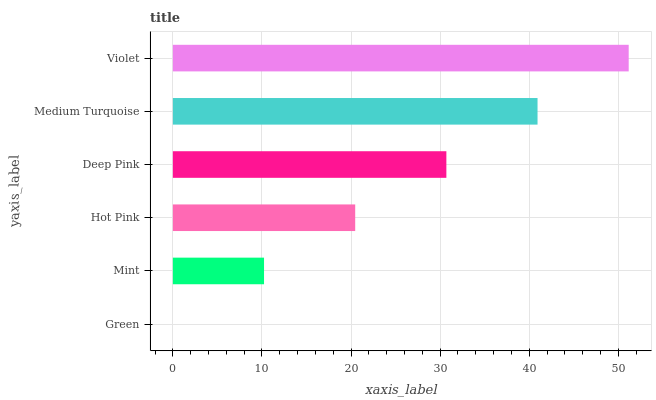Is Green the minimum?
Answer yes or no. Yes. Is Violet the maximum?
Answer yes or no. Yes. Is Mint the minimum?
Answer yes or no. No. Is Mint the maximum?
Answer yes or no. No. Is Mint greater than Green?
Answer yes or no. Yes. Is Green less than Mint?
Answer yes or no. Yes. Is Green greater than Mint?
Answer yes or no. No. Is Mint less than Green?
Answer yes or no. No. Is Deep Pink the high median?
Answer yes or no. Yes. Is Hot Pink the low median?
Answer yes or no. Yes. Is Violet the high median?
Answer yes or no. No. Is Mint the low median?
Answer yes or no. No. 